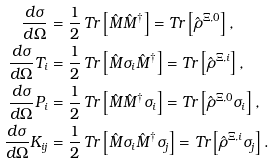Convert formula to latex. <formula><loc_0><loc_0><loc_500><loc_500>\frac { d \sigma } { d \Omega } & = \frac { 1 } { 2 } \, T r \left [ \hat { M } \hat { M } ^ { \dagger } \right ] = T r \left [ \hat { \rho } ^ { \Xi , 0 } \right ] , \\ \frac { d \sigma } { d \Omega } T _ { i } & = \frac { 1 } { 2 } \, T r \left [ \hat { M } \sigma _ { i } \hat { M } ^ { \dagger } \right ] = T r \left [ \hat { \rho } ^ { \Xi , i } \right ] , \\ \frac { d \sigma } { d \Omega } P _ { i } & = \frac { 1 } { 2 } \, T r \left [ \hat { M } \hat { M } ^ { \dagger } \sigma _ { i } \right ] = T r \left [ \hat { \rho } ^ { \Xi , 0 } \sigma _ { i } \right ] , \\ \frac { d \sigma } { d \Omega } K _ { i j } & = \frac { 1 } { 2 } \, T r \left [ \hat { M } \sigma _ { i } \hat { M } ^ { \dagger } \sigma _ { j } \right ] = T r \left [ \hat { \rho } ^ { \Xi , i } \sigma _ { j } \right ] .</formula> 